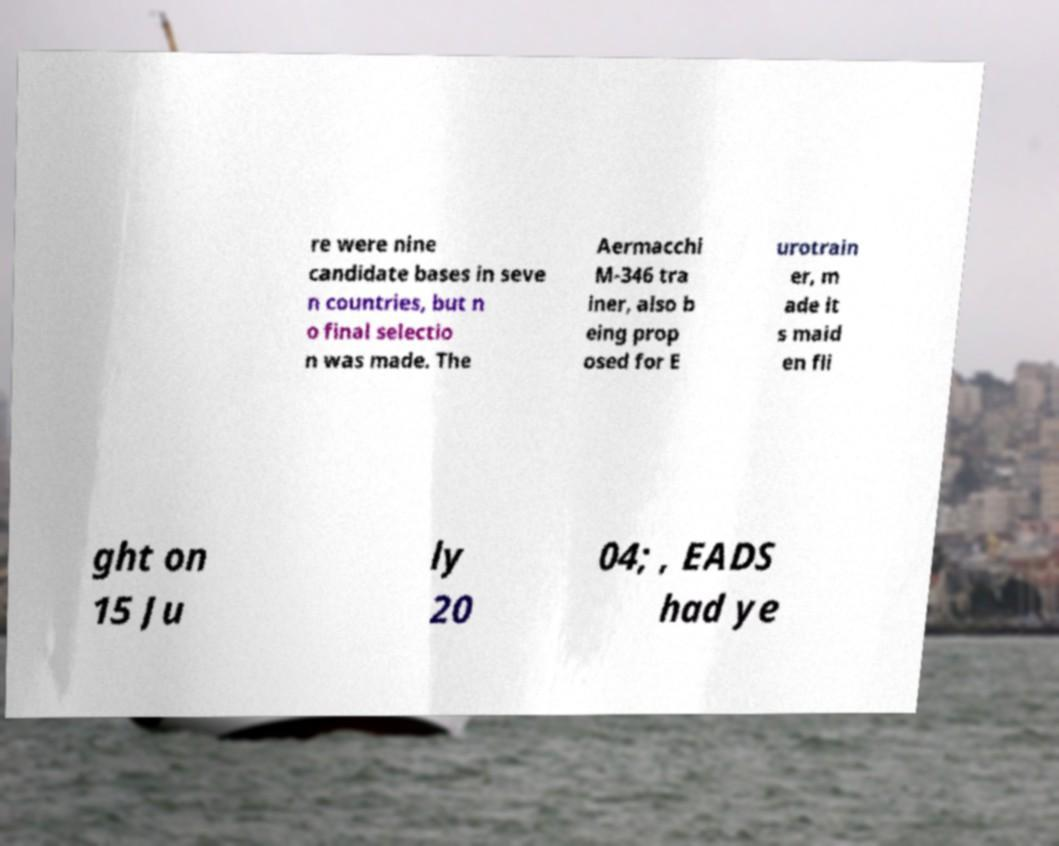For documentation purposes, I need the text within this image transcribed. Could you provide that? re were nine candidate bases in seve n countries, but n o final selectio n was made. The Aermacchi M-346 tra iner, also b eing prop osed for E urotrain er, m ade it s maid en fli ght on 15 Ju ly 20 04; , EADS had ye 